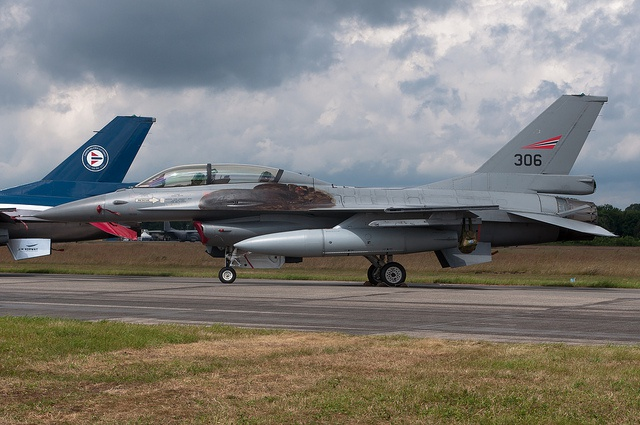Describe the objects in this image and their specific colors. I can see airplane in darkgray, black, and gray tones, airplane in darkgray, blue, darkblue, black, and lightgray tones, people in darkgray, gray, black, and navy tones, and people in darkgray, black, teal, and gray tones in this image. 